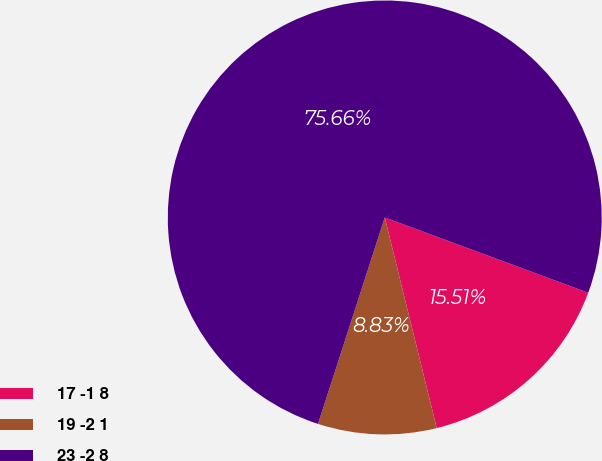Convert chart to OTSL. <chart><loc_0><loc_0><loc_500><loc_500><pie_chart><fcel>17 -1 8<fcel>19 -2 1<fcel>23 -2 8<nl><fcel>15.51%<fcel>8.83%<fcel>75.66%<nl></chart> 